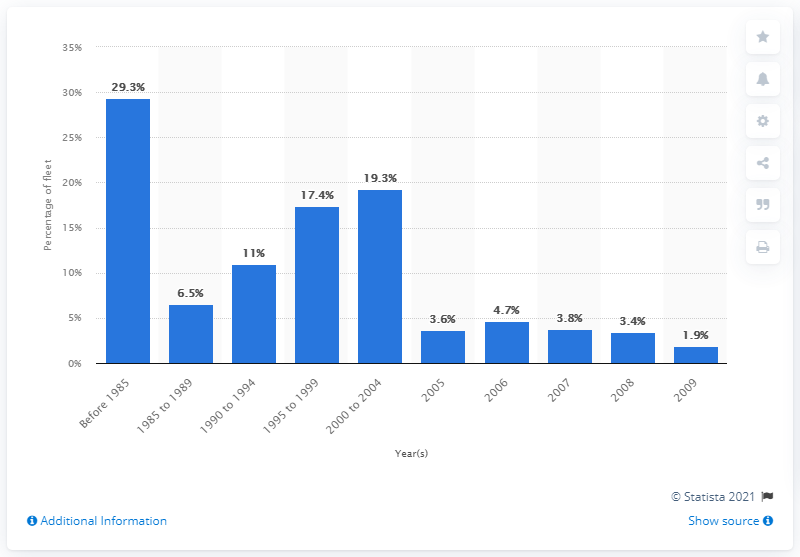Draw attention to some important aspects in this diagram. In 2008, approximately 3.4% of the entire U.S. class I locomotive fleet was manufactured. 